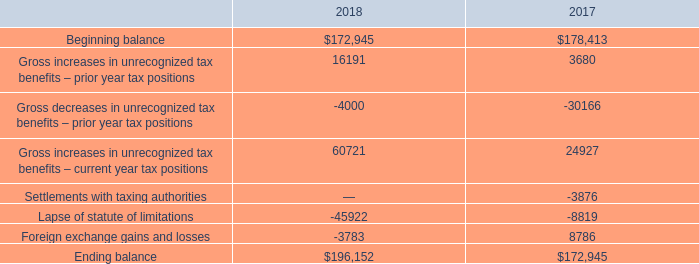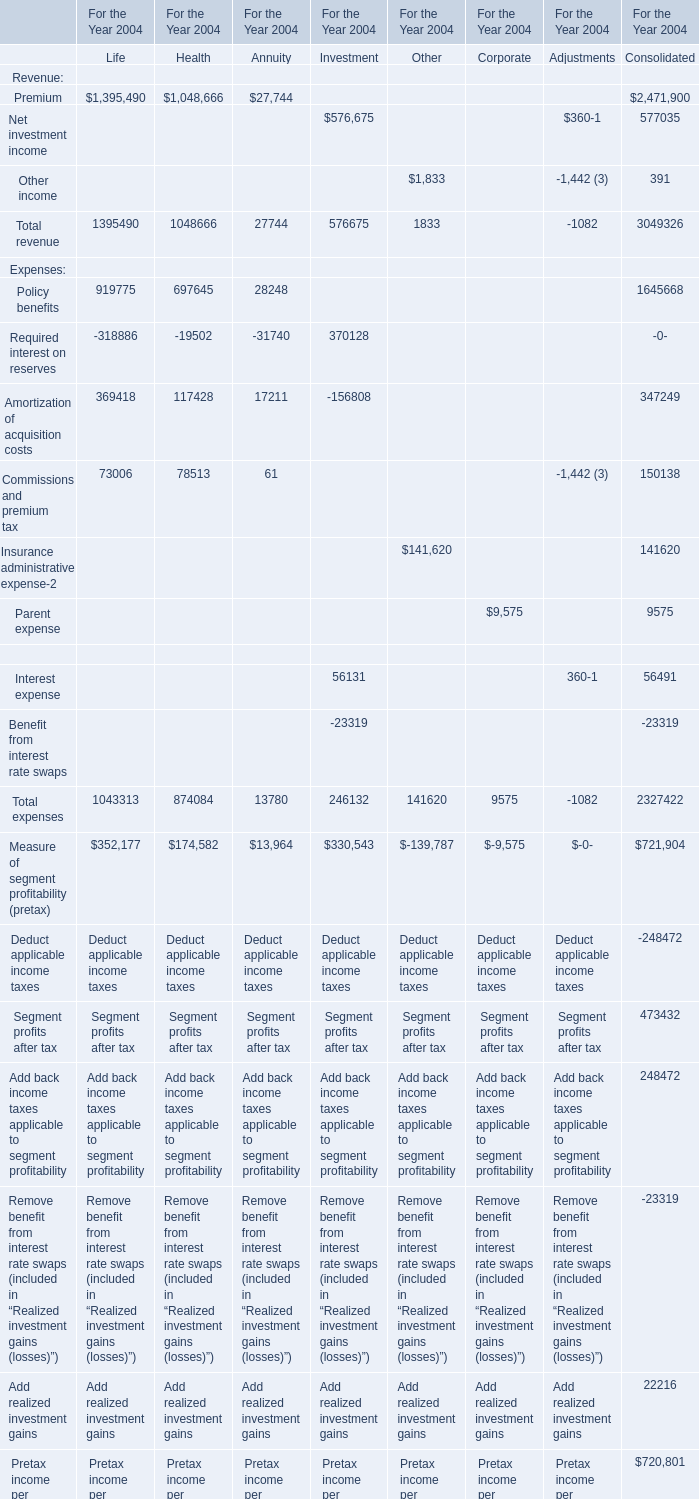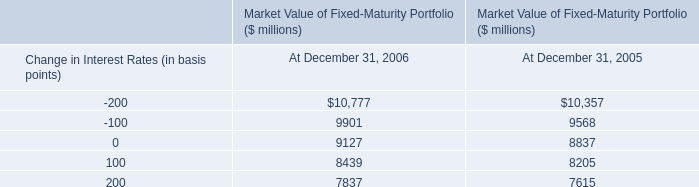what is the percentage change in total gross amount of unrecognized tax benefits from 2016 to 2017? 
Computations: ((172945 - 178413) / 178413)
Answer: -0.03065. 